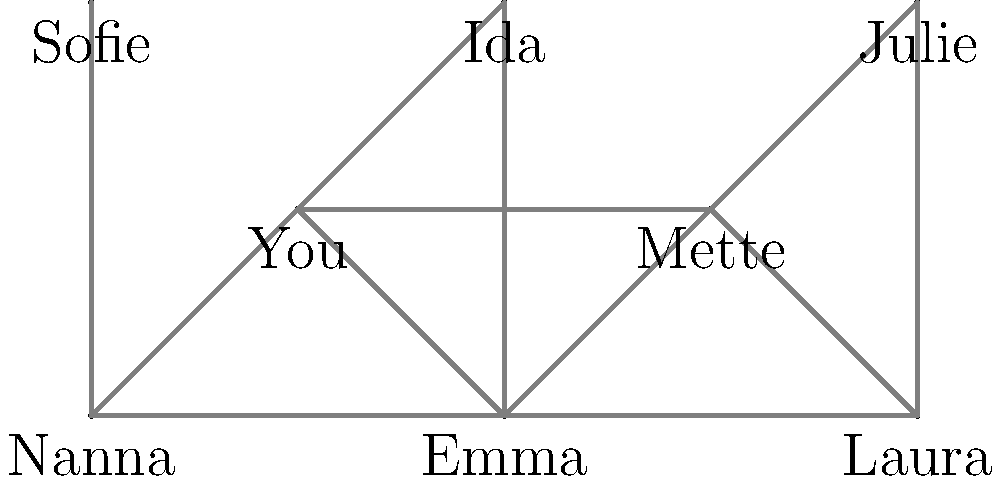Remember our old passing network in IK Skovbakken? Looking at this graph representing our team's connectivity, what is the minimum number of players that need to be removed to disconnect Nanna from Julie completely? To solve this problem, we need to find the minimum number of vertex-disjoint paths between Nanna and Julie. This is equivalent to finding the minimum number of vertices that need to be removed to disconnect these two players.

Let's analyze the possible paths from Nanna to Julie:

1. Nanna → You → Mette → Julie
2. Nanna → Emma → Mette → Julie
3. Nanna → Emma → Laura → Julie

To disconnect Nanna from Julie, we need to remove at least one player from each of these paths. The minimum number of players to remove would be the maximum number of vertex-disjoint paths.

In this case, we can see that there are 3 vertex-disjoint paths:
1. Nanna → You → Mette → Julie
2. Nanna → Emma → Laura → Julie
3. Nanna → Sofie (This path doesn't reach Julie, but it's an additional connection that needs to be considered)

Therefore, to completely disconnect Nanna from Julie, we need to remove at least 3 players. This could be achieved by removing, for example, You, Emma, and Sofie.

This concept in graph theory is related to the vertex connectivity of the graph between Nanna and Julie, which is 3 in this case.
Answer: 3 players 